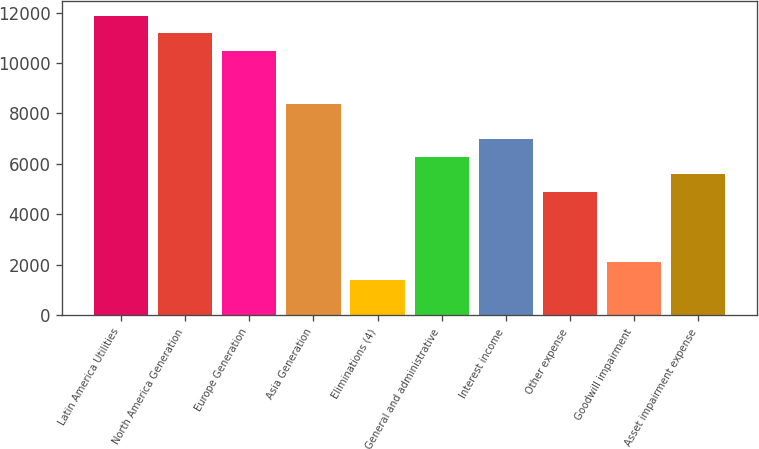<chart> <loc_0><loc_0><loc_500><loc_500><bar_chart><fcel>Latin America Utilities<fcel>North America Generation<fcel>Europe Generation<fcel>Asia Generation<fcel>Eliminations (4)<fcel>General and administrative<fcel>Interest income<fcel>Other expense<fcel>Goodwill impairment<fcel>Asset impairment expense<nl><fcel>11877.5<fcel>11178.9<fcel>10480.2<fcel>8384.31<fcel>1397.91<fcel>6288.39<fcel>6987.03<fcel>4891.11<fcel>2096.55<fcel>5589.75<nl></chart> 